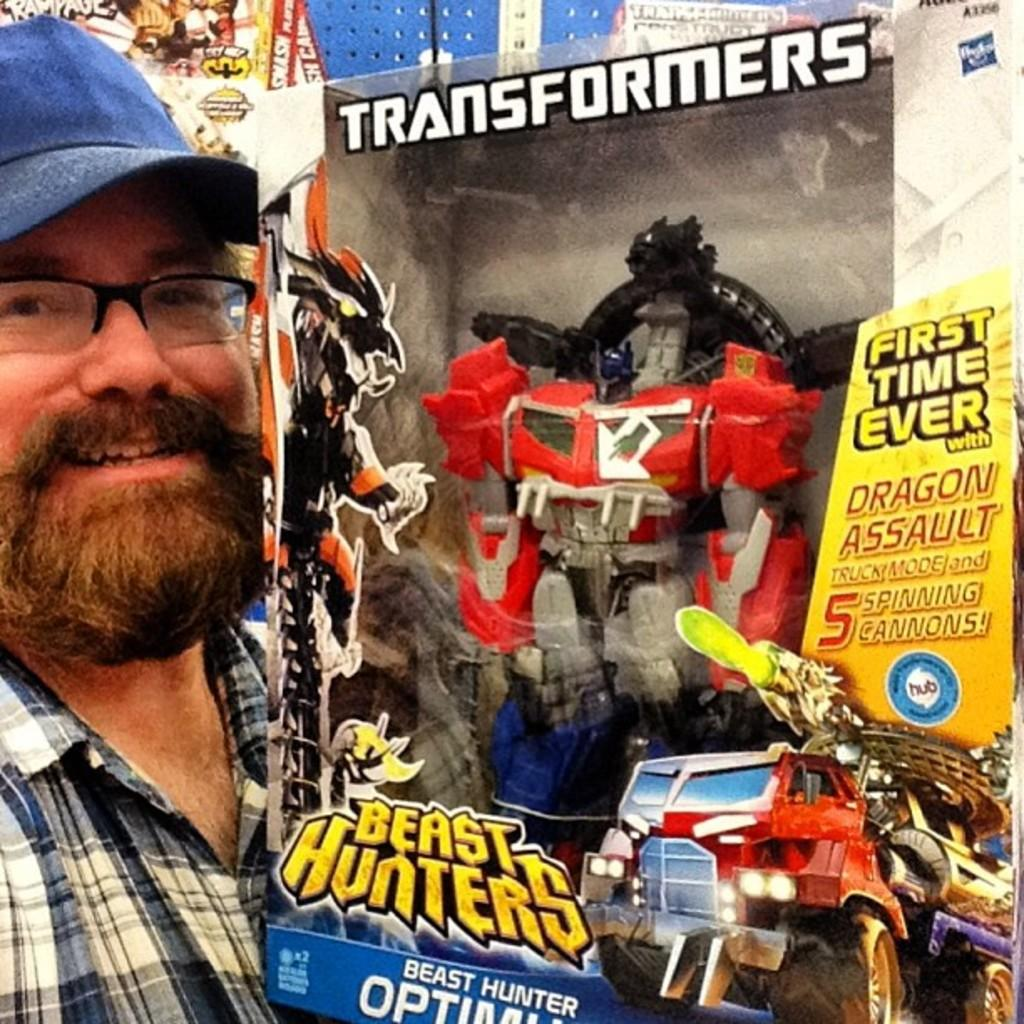Who or what is present in the image? There is a person in the image. What is the person holding in the image? The person is holding a cardboard box. What can be found inside the cardboard box? There is a toy inside the cardboard box. How is the cardboard box decorated or labeled? There are stickers attached to the cardboard box. What type of sugar is being used to cover the person's throat in the image? There is no sugar or reference to a throat in the image; it features a person holding a cardboard box with a toy and stickers. 